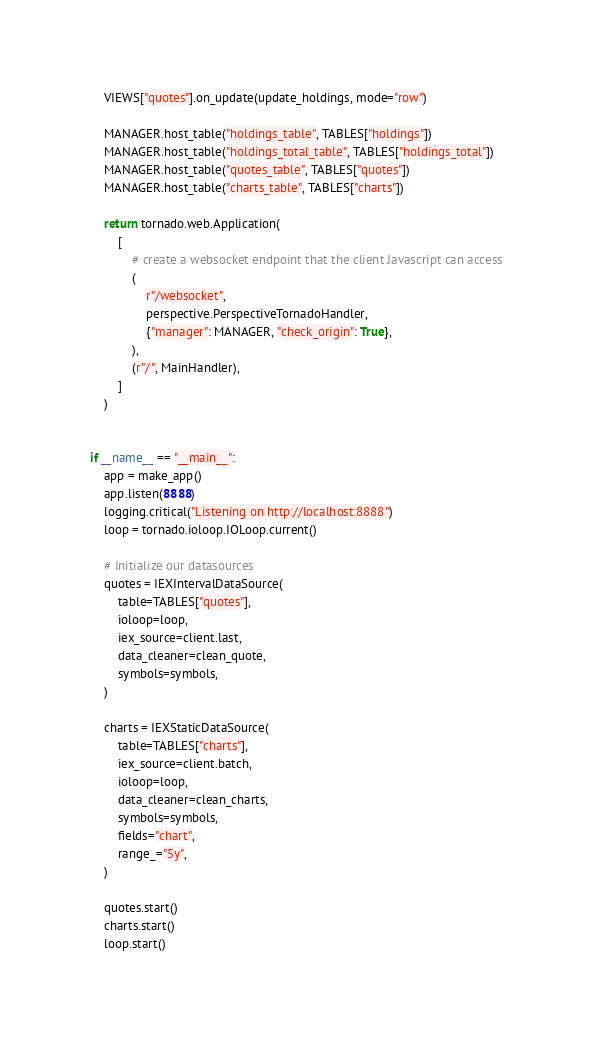Convert code to text. <code><loc_0><loc_0><loc_500><loc_500><_Python_>
    VIEWS["quotes"].on_update(update_holdings, mode="row")

    MANAGER.host_table("holdings_table", TABLES["holdings"])
    MANAGER.host_table("holdings_total_table", TABLES["holdings_total"])
    MANAGER.host_table("quotes_table", TABLES["quotes"])
    MANAGER.host_table("charts_table", TABLES["charts"])
    
    return tornado.web.Application(
        [
            # create a websocket endpoint that the client Javascript can access
            (
                r"/websocket",
                perspective.PerspectiveTornadoHandler,
                {"manager": MANAGER, "check_origin": True},
            ),
            (r"/", MainHandler),
        ]
    )


if __name__ == "__main__":
    app = make_app()
    app.listen(8888)
    logging.critical("Listening on http://localhost:8888")
    loop = tornado.ioloop.IOLoop.current()

    # Initialize our datasources
    quotes = IEXIntervalDataSource(
        table=TABLES["quotes"],
        ioloop=loop,
        iex_source=client.last,
        data_cleaner=clean_quote,
        symbols=symbols,
    )

    charts = IEXStaticDataSource(
        table=TABLES["charts"],
        iex_source=client.batch,
        ioloop=loop,
        data_cleaner=clean_charts,
        symbols=symbols,
        fields="chart",
        range_="5y",
    )

    quotes.start()
    charts.start()
    loop.start()
</code> 